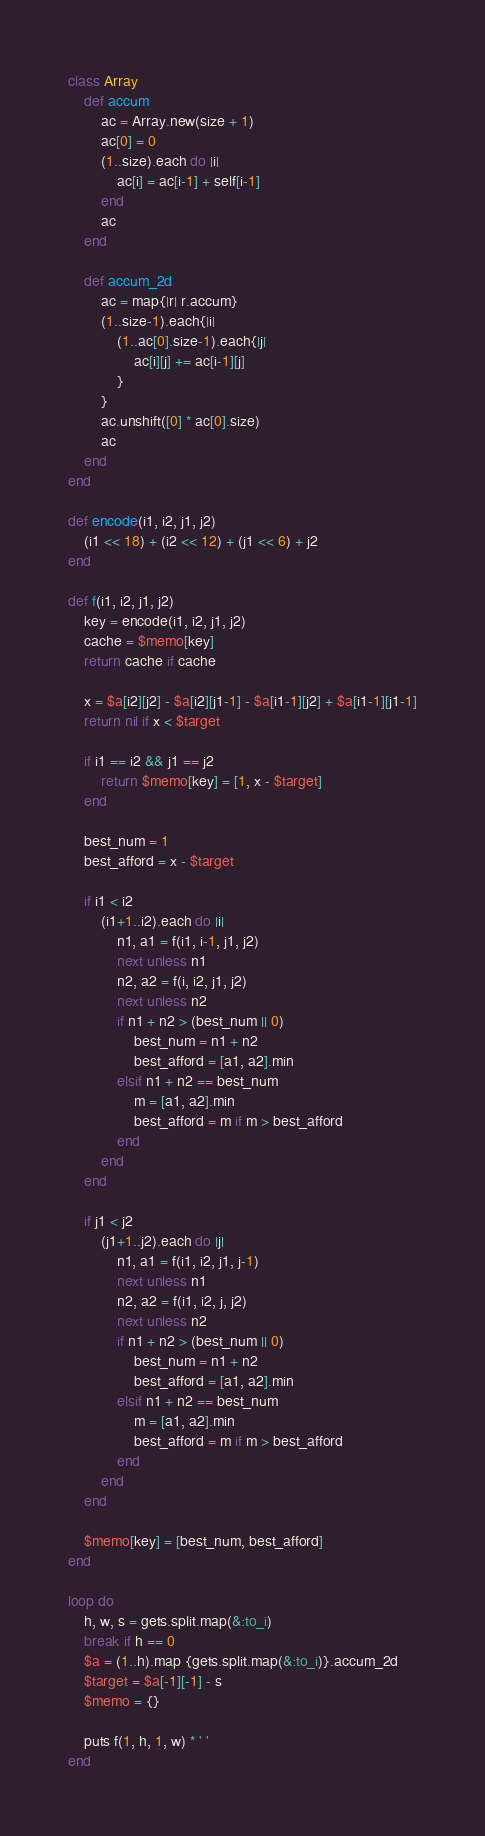Convert code to text. <code><loc_0><loc_0><loc_500><loc_500><_Ruby_>class Array
	def accum
		ac = Array.new(size + 1)
		ac[0] = 0
		(1..size).each do |i|
			ac[i] = ac[i-1] + self[i-1]
		end
		ac
	end

	def accum_2d
		ac = map{|r| r.accum}
		(1..size-1).each{|i|
			(1..ac[0].size-1).each{|j|
				ac[i][j] += ac[i-1][j]
			}
		}
		ac.unshift([0] * ac[0].size)
		ac
	end
end		

def encode(i1, i2, j1, j2)
    (i1 << 18) + (i2 << 12) + (j1 << 6) + j2
end

def f(i1, i2, j1, j2)
    key = encode(i1, i2, j1, j2)
    cache = $memo[key]
    return cache if cache

    x = $a[i2][j2] - $a[i2][j1-1] - $a[i1-1][j2] + $a[i1-1][j1-1]
    return nil if x < $target

    if i1 == i2 && j1 == j2
        return $memo[key] = [1, x - $target]
    end

    best_num = 1
    best_afford = x - $target

    if i1 < i2
        (i1+1..i2).each do |i|
            n1, a1 = f(i1, i-1, j1, j2)
            next unless n1
            n2, a2 = f(i, i2, j1, j2)
            next unless n2
            if n1 + n2 > (best_num || 0)
                best_num = n1 + n2
                best_afford = [a1, a2].min
            elsif n1 + n2 == best_num
                m = [a1, a2].min
                best_afford = m if m > best_afford
            end
        end
    end

    if j1 < j2
        (j1+1..j2).each do |j|
            n1, a1 = f(i1, i2, j1, j-1)
            next unless n1
            n2, a2 = f(i1, i2, j, j2)
            next unless n2
            if n1 + n2 > (best_num || 0)
                best_num = n1 + n2
                best_afford = [a1, a2].min
            elsif n1 + n2 == best_num
                m = [a1, a2].min
                best_afford = m if m > best_afford
            end
        end
    end

    $memo[key] = [best_num, best_afford]
end

loop do
    h, w, s = gets.split.map(&:to_i)
    break if h == 0
    $a = (1..h).map {gets.split.map(&:to_i)}.accum_2d
    $target = $a[-1][-1] - s
    $memo = {}

    puts f(1, h, 1, w) * ' '
end</code> 